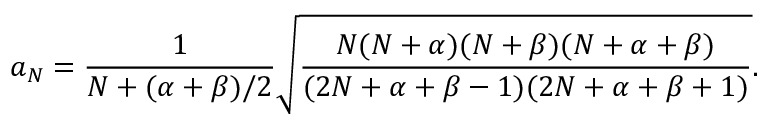Convert formula to latex. <formula><loc_0><loc_0><loc_500><loc_500>a _ { N } = { \frac { 1 } { N + ( \alpha + \beta ) / 2 } } \sqrt { { \frac { N ( N + \alpha ) ( N + \beta ) ( N + \alpha + \beta ) } { ( 2 N + \alpha + \beta - 1 ) ( 2 N + \alpha + \beta + 1 ) } } } .</formula> 